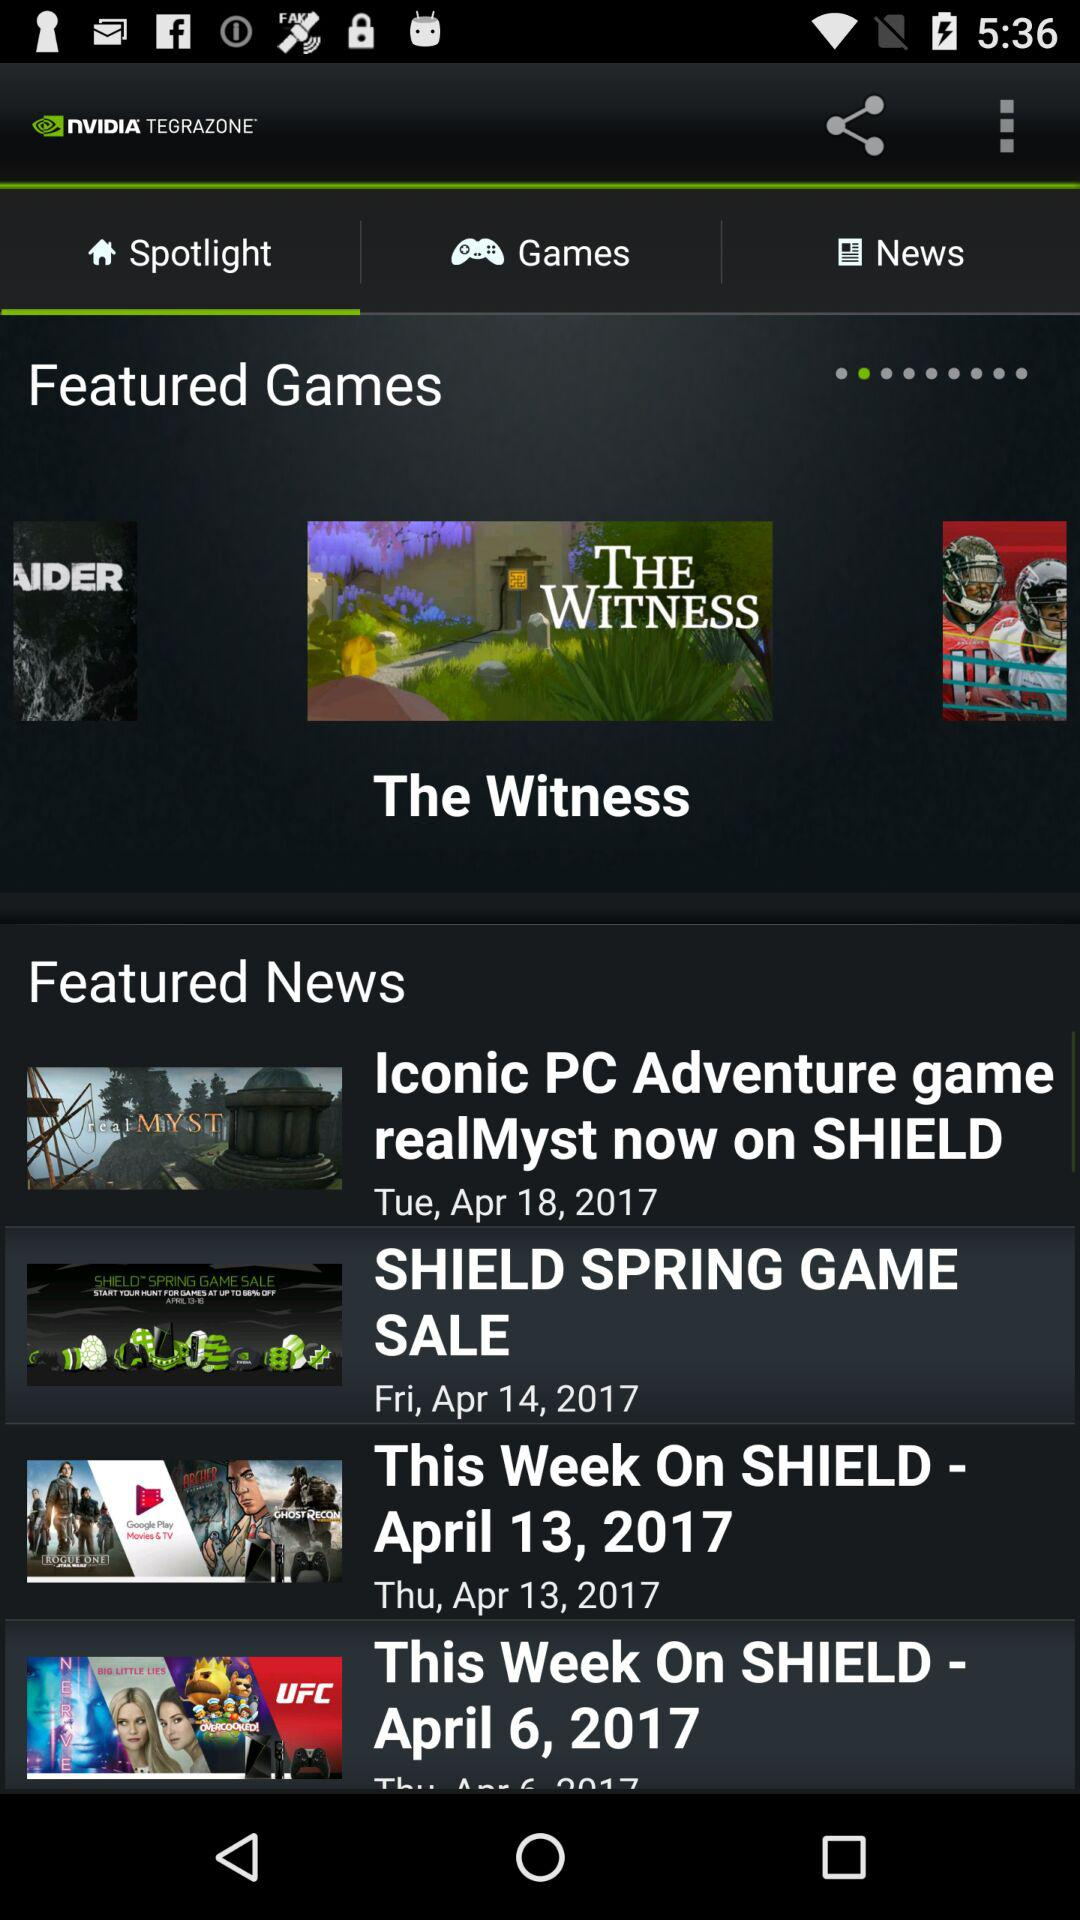Which tab is selected? The selected tab is "Spotlight". 